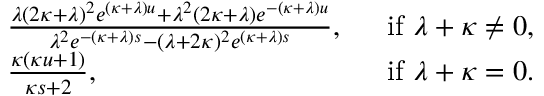<formula> <loc_0><loc_0><loc_500><loc_500>\begin{array} { r l r } & { \frac { \lambda ( 2 \kappa + \lambda ) ^ { 2 } e ^ { ( \kappa + \lambda ) u } + \lambda ^ { 2 } ( 2 \kappa + \lambda ) e ^ { - ( \kappa + \lambda ) u } } { \lambda ^ { 2 } e ^ { - ( \kappa + \lambda ) s } - ( \lambda + 2 \kappa ) ^ { 2 } e ^ { ( \kappa + \lambda ) s } } , } & { i f \lambda + \kappa \neq 0 , } \\ & { \frac { \kappa ( \kappa u + 1 ) } { \kappa s + 2 } , } & { i f \lambda + \kappa = 0 . } \end{array}</formula> 